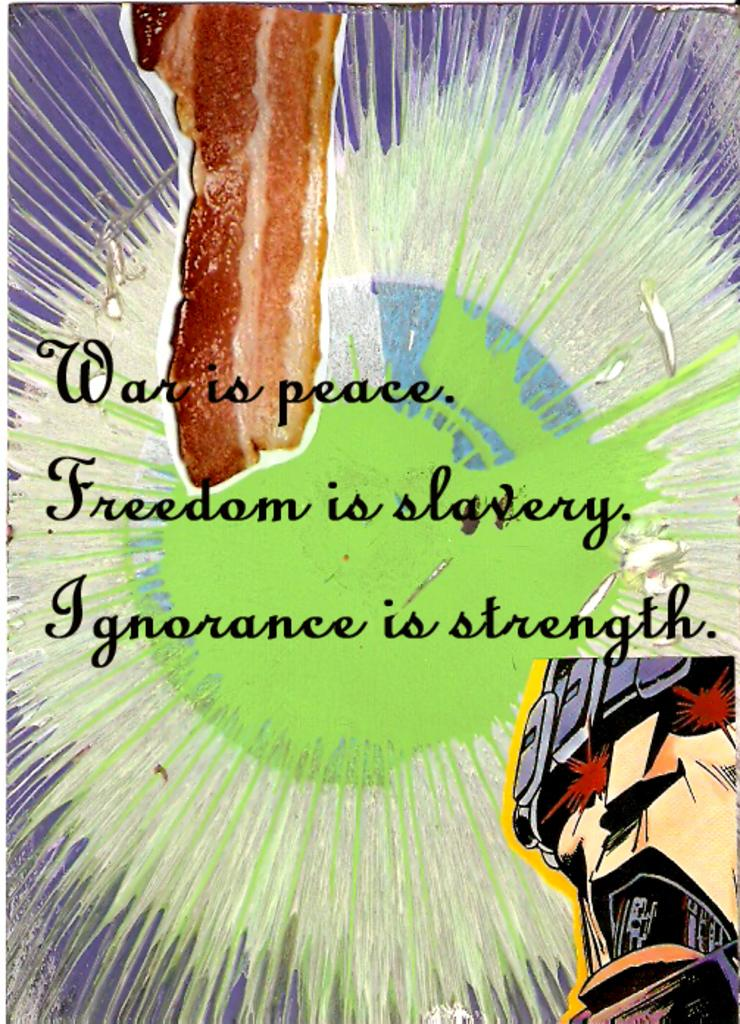<image>
Write a terse but informative summary of the picture. a page that says 'war is peace. freedom is slavery. ignorance is strenght. 